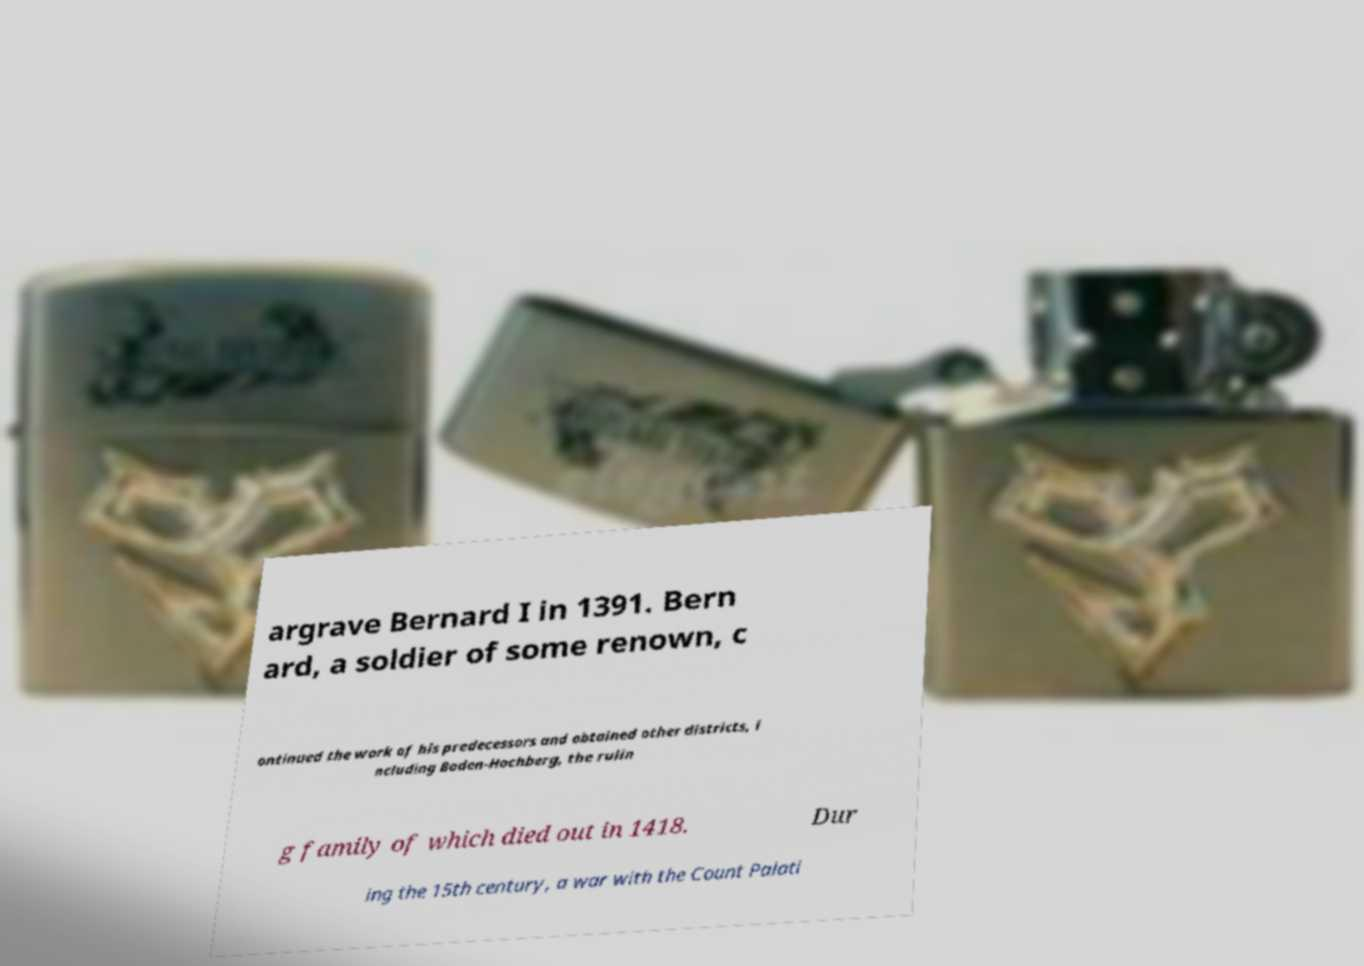Could you extract and type out the text from this image? argrave Bernard I in 1391. Bern ard, a soldier of some renown, c ontinued the work of his predecessors and obtained other districts, i ncluding Baden-Hochberg, the rulin g family of which died out in 1418. Dur ing the 15th century, a war with the Count Palati 